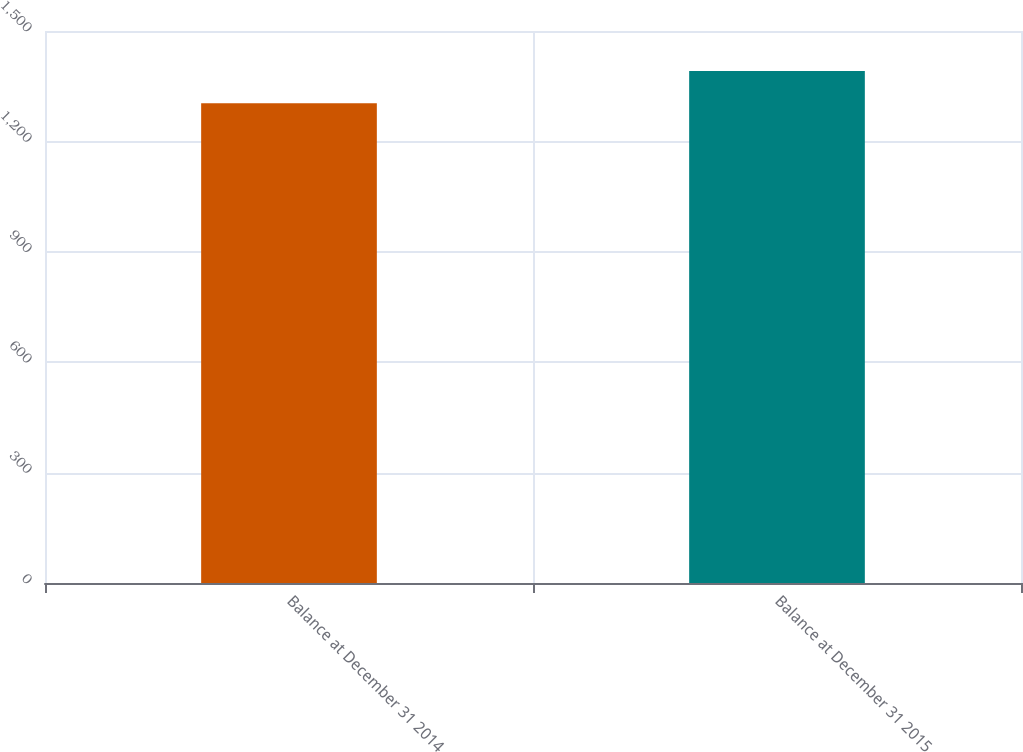Convert chart. <chart><loc_0><loc_0><loc_500><loc_500><bar_chart><fcel>Balance at December 31 2014<fcel>Balance at December 31 2015<nl><fcel>1304<fcel>1391<nl></chart> 